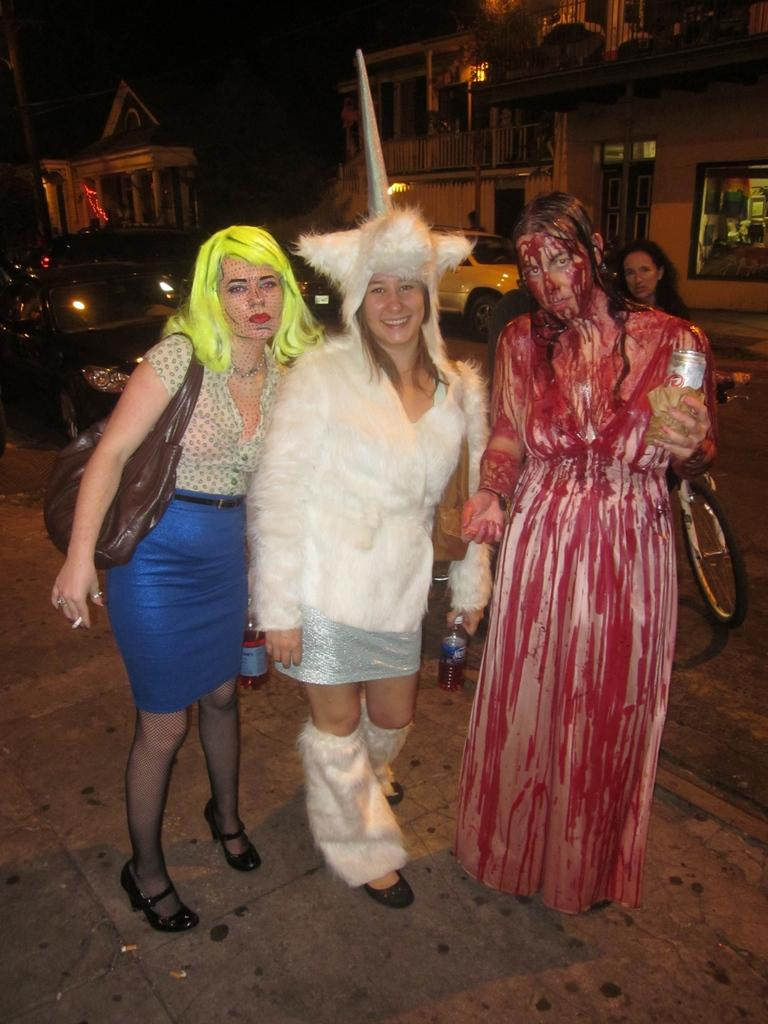Who or what can be seen in the image? There are people in the image. What else is present in the image besides people? There are vehicles, houses, the ground, a bicycle, and a pole in the image. Can you describe the vehicles in the image? The vehicles in the image are not specified, but they are present. What is the ground like in the image? The ground is visible in the image, but its specific characteristics are not mentioned. What type of butter is being used to grease the scarecrow in the image? There is no butter or scarecrow present in the image. 